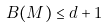Convert formula to latex. <formula><loc_0><loc_0><loc_500><loc_500>\ B ( M ) \leq d + 1</formula> 